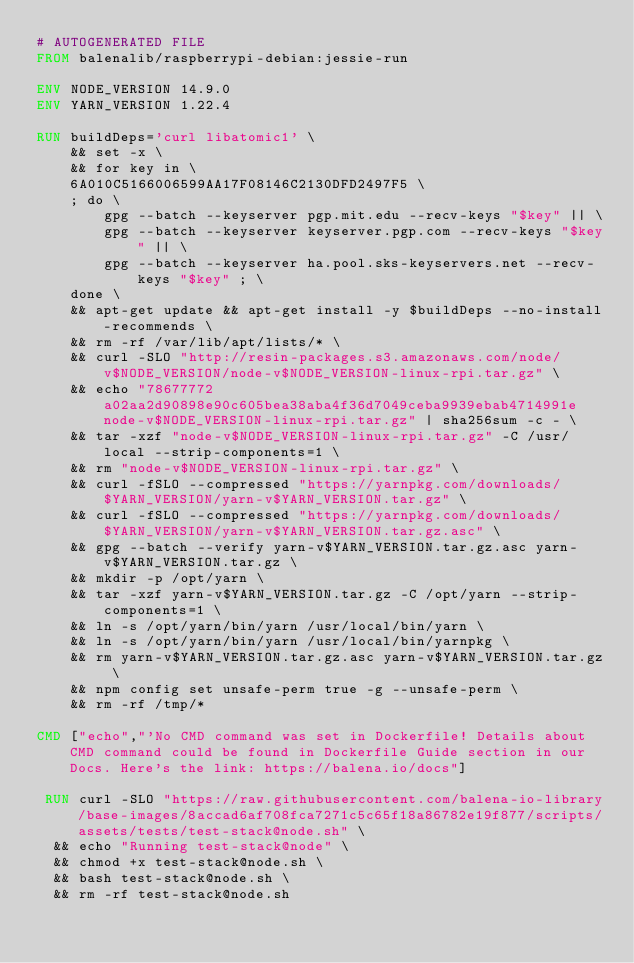Convert code to text. <code><loc_0><loc_0><loc_500><loc_500><_Dockerfile_># AUTOGENERATED FILE
FROM balenalib/raspberrypi-debian:jessie-run

ENV NODE_VERSION 14.9.0
ENV YARN_VERSION 1.22.4

RUN buildDeps='curl libatomic1' \
	&& set -x \
	&& for key in \
	6A010C5166006599AA17F08146C2130DFD2497F5 \
	; do \
		gpg --batch --keyserver pgp.mit.edu --recv-keys "$key" || \
		gpg --batch --keyserver keyserver.pgp.com --recv-keys "$key" || \
		gpg --batch --keyserver ha.pool.sks-keyservers.net --recv-keys "$key" ; \
	done \
	&& apt-get update && apt-get install -y $buildDeps --no-install-recommends \
	&& rm -rf /var/lib/apt/lists/* \
	&& curl -SLO "http://resin-packages.s3.amazonaws.com/node/v$NODE_VERSION/node-v$NODE_VERSION-linux-rpi.tar.gz" \
	&& echo "78677772a02aa2d90898e90c605bea38aba4f36d7049ceba9939ebab4714991e  node-v$NODE_VERSION-linux-rpi.tar.gz" | sha256sum -c - \
	&& tar -xzf "node-v$NODE_VERSION-linux-rpi.tar.gz" -C /usr/local --strip-components=1 \
	&& rm "node-v$NODE_VERSION-linux-rpi.tar.gz" \
	&& curl -fSLO --compressed "https://yarnpkg.com/downloads/$YARN_VERSION/yarn-v$YARN_VERSION.tar.gz" \
	&& curl -fSLO --compressed "https://yarnpkg.com/downloads/$YARN_VERSION/yarn-v$YARN_VERSION.tar.gz.asc" \
	&& gpg --batch --verify yarn-v$YARN_VERSION.tar.gz.asc yarn-v$YARN_VERSION.tar.gz \
	&& mkdir -p /opt/yarn \
	&& tar -xzf yarn-v$YARN_VERSION.tar.gz -C /opt/yarn --strip-components=1 \
	&& ln -s /opt/yarn/bin/yarn /usr/local/bin/yarn \
	&& ln -s /opt/yarn/bin/yarn /usr/local/bin/yarnpkg \
	&& rm yarn-v$YARN_VERSION.tar.gz.asc yarn-v$YARN_VERSION.tar.gz \
	&& npm config set unsafe-perm true -g --unsafe-perm \
	&& rm -rf /tmp/*

CMD ["echo","'No CMD command was set in Dockerfile! Details about CMD command could be found in Dockerfile Guide section in our Docs. Here's the link: https://balena.io/docs"]

 RUN curl -SLO "https://raw.githubusercontent.com/balena-io-library/base-images/8accad6af708fca7271c5c65f18a86782e19f877/scripts/assets/tests/test-stack@node.sh" \
  && echo "Running test-stack@node" \
  && chmod +x test-stack@node.sh \
  && bash test-stack@node.sh \
  && rm -rf test-stack@node.sh 
</code> 